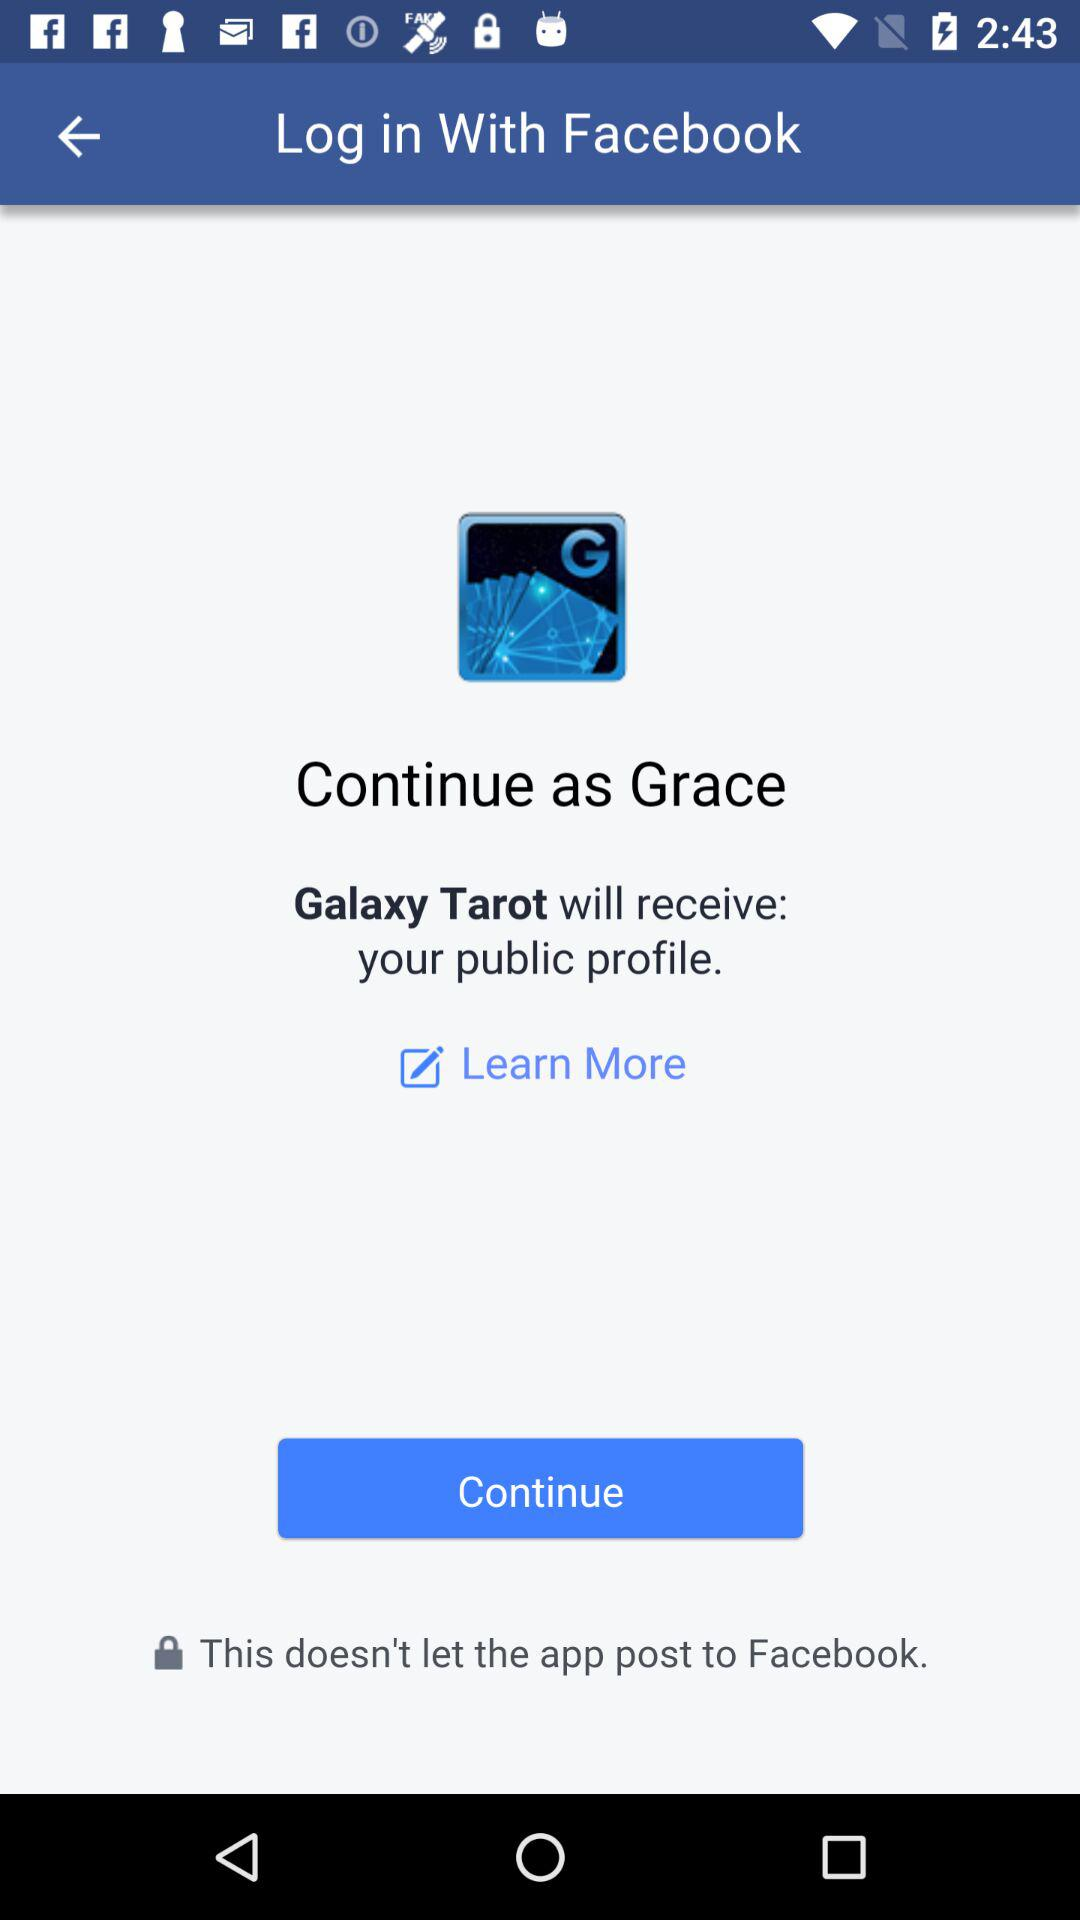What is the name of the user? The name of the user is Grace. 